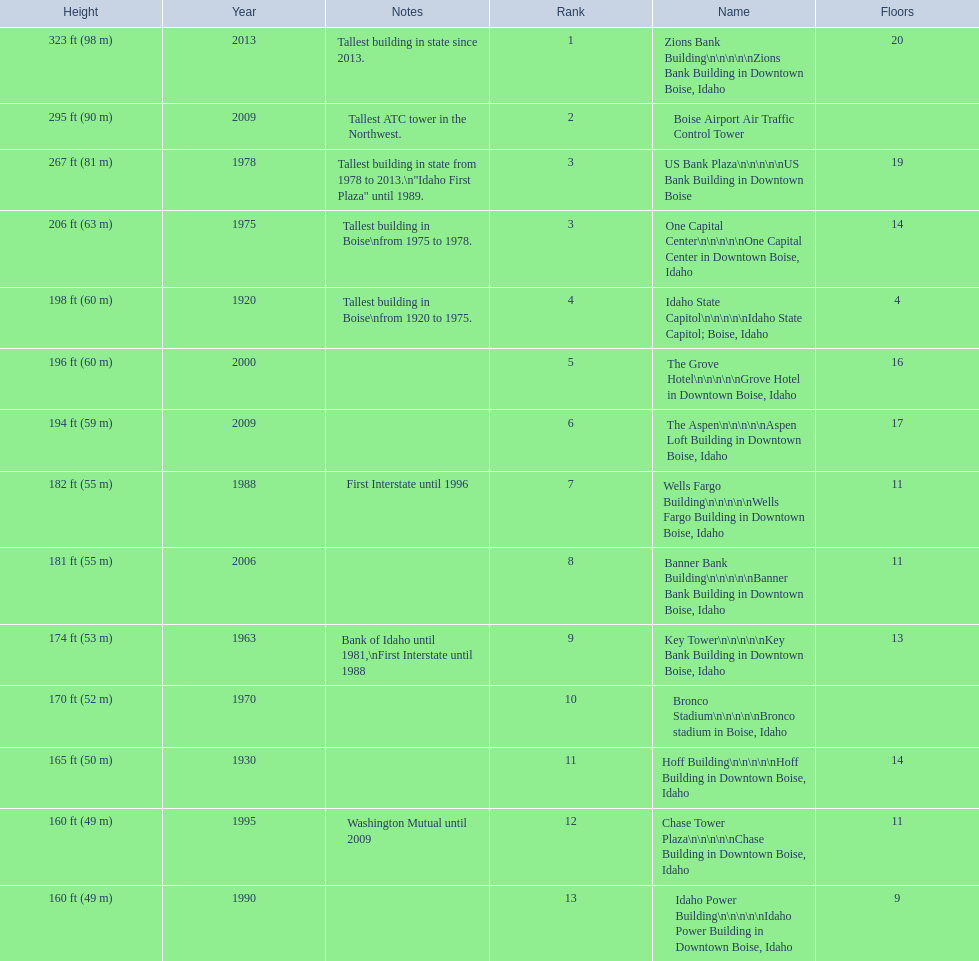How many floors does the tallest building have? 20. 